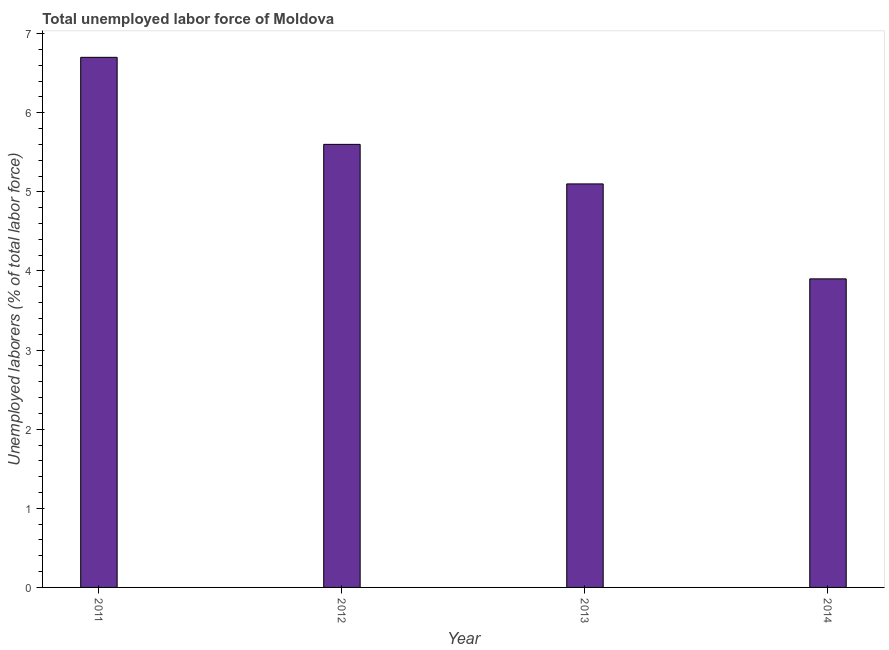Does the graph contain any zero values?
Give a very brief answer. No. What is the title of the graph?
Ensure brevity in your answer.  Total unemployed labor force of Moldova. What is the label or title of the X-axis?
Keep it short and to the point. Year. What is the label or title of the Y-axis?
Provide a short and direct response. Unemployed laborers (% of total labor force). What is the total unemployed labour force in 2013?
Your response must be concise. 5.1. Across all years, what is the maximum total unemployed labour force?
Keep it short and to the point. 6.7. Across all years, what is the minimum total unemployed labour force?
Offer a terse response. 3.9. What is the sum of the total unemployed labour force?
Offer a very short reply. 21.3. What is the average total unemployed labour force per year?
Your answer should be compact. 5.33. What is the median total unemployed labour force?
Make the answer very short. 5.35. In how many years, is the total unemployed labour force greater than 4 %?
Your response must be concise. 3. Do a majority of the years between 2014 and 2012 (inclusive) have total unemployed labour force greater than 3.6 %?
Your response must be concise. Yes. What is the ratio of the total unemployed labour force in 2011 to that in 2014?
Provide a succinct answer. 1.72. What is the difference between the highest and the second highest total unemployed labour force?
Offer a terse response. 1.1. Is the sum of the total unemployed labour force in 2012 and 2013 greater than the maximum total unemployed labour force across all years?
Ensure brevity in your answer.  Yes. What is the difference between the highest and the lowest total unemployed labour force?
Your answer should be very brief. 2.8. What is the difference between two consecutive major ticks on the Y-axis?
Your response must be concise. 1. What is the Unemployed laborers (% of total labor force) in 2011?
Your response must be concise. 6.7. What is the Unemployed laborers (% of total labor force) in 2012?
Ensure brevity in your answer.  5.6. What is the Unemployed laborers (% of total labor force) of 2013?
Offer a terse response. 5.1. What is the Unemployed laborers (% of total labor force) in 2014?
Offer a very short reply. 3.9. What is the difference between the Unemployed laborers (% of total labor force) in 2011 and 2013?
Give a very brief answer. 1.6. What is the difference between the Unemployed laborers (% of total labor force) in 2012 and 2013?
Provide a short and direct response. 0.5. What is the ratio of the Unemployed laborers (% of total labor force) in 2011 to that in 2012?
Ensure brevity in your answer.  1.2. What is the ratio of the Unemployed laborers (% of total labor force) in 2011 to that in 2013?
Your answer should be very brief. 1.31. What is the ratio of the Unemployed laborers (% of total labor force) in 2011 to that in 2014?
Make the answer very short. 1.72. What is the ratio of the Unemployed laborers (% of total labor force) in 2012 to that in 2013?
Keep it short and to the point. 1.1. What is the ratio of the Unemployed laborers (% of total labor force) in 2012 to that in 2014?
Provide a short and direct response. 1.44. What is the ratio of the Unemployed laborers (% of total labor force) in 2013 to that in 2014?
Your answer should be compact. 1.31. 